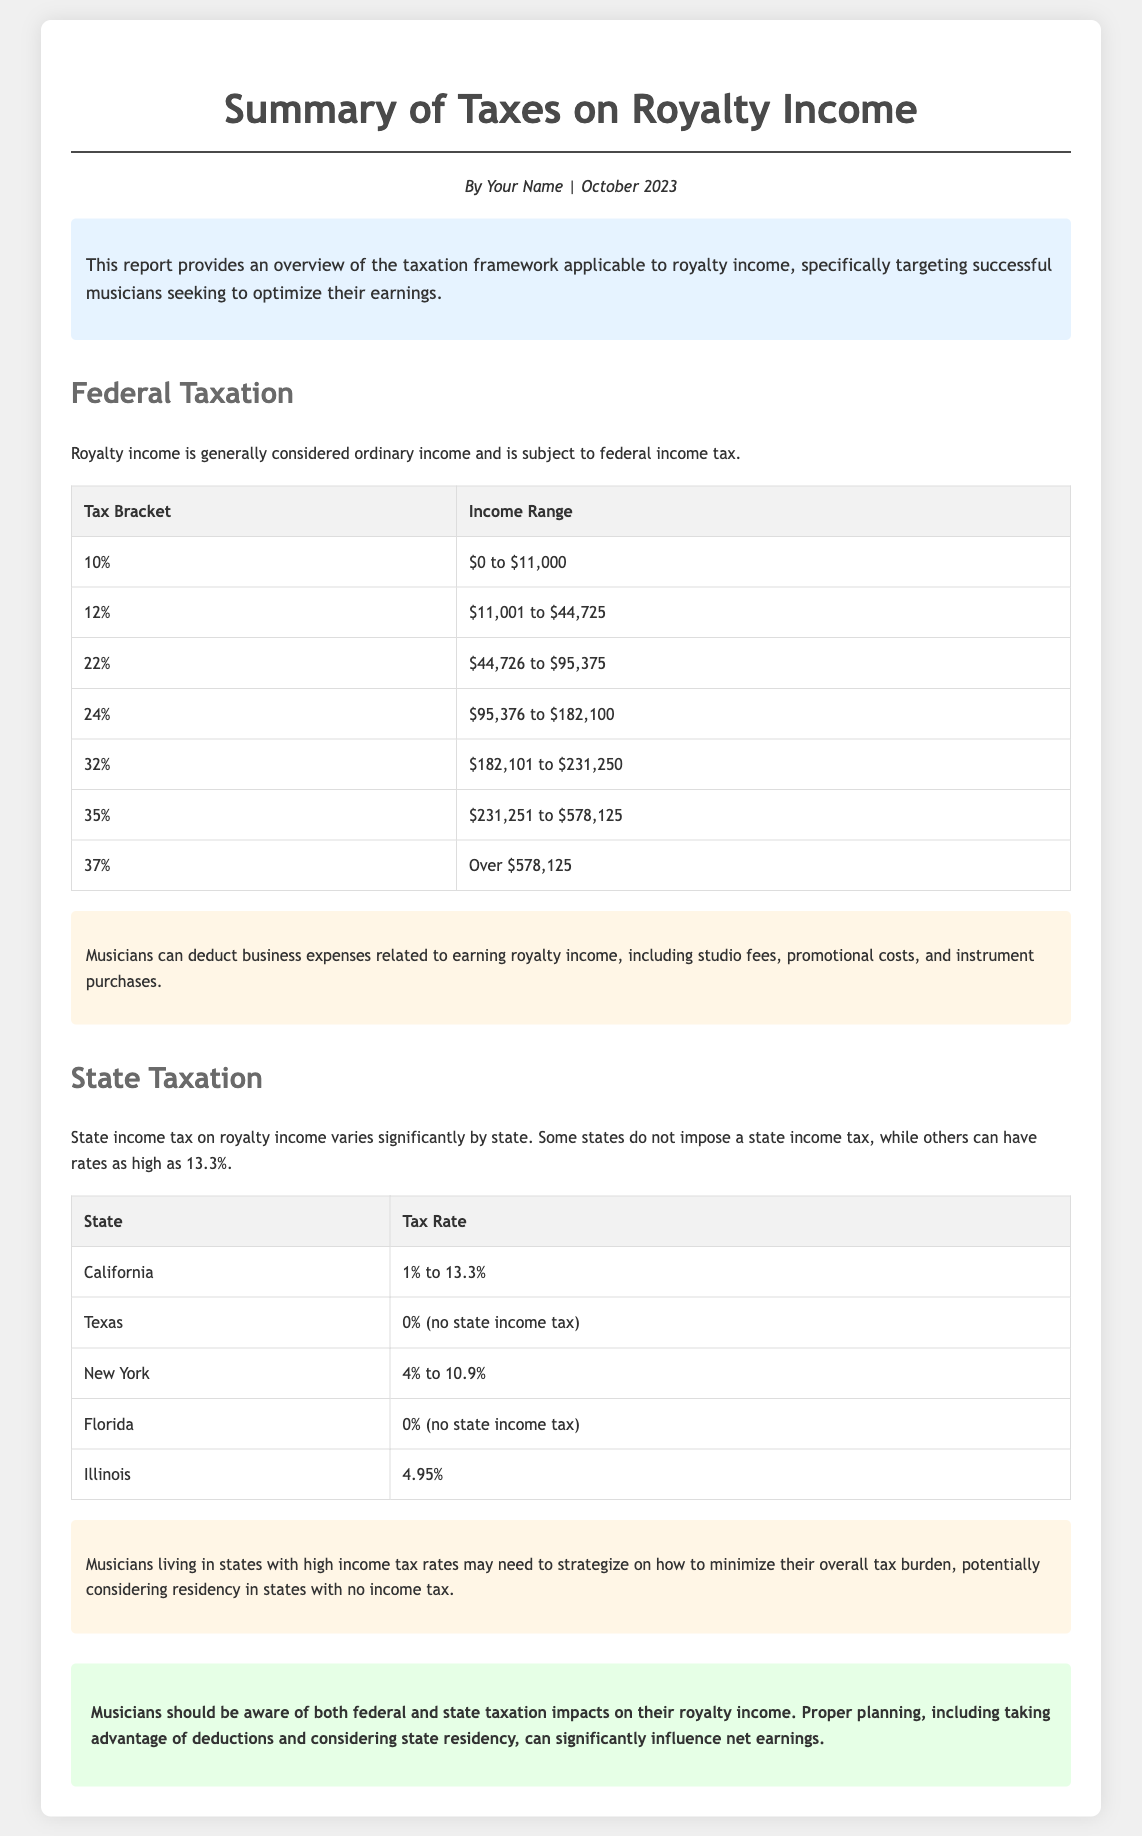What is the federal tax rate for income up to $11,000? The document lists the tax bracket of 10% for income ranging from $0 to $11,000.
Answer: 10% What is the maximum federal tax bracket mentioned in the document? The document indicates the highest tax bracket of 37% for income over $578,125.
Answer: 37% In which month and year is this report published? The author-date section states that the report is dated October 2023.
Answer: October 2023 Which state has the highest possible income tax rate on royalty income? The document specifies California with a tax rate as high as 13.3%.
Answer: California What expenses can musicians deduct from their royalty income? The document mentions studio fees, promotional costs, and instrument purchases as deductible business expenses.
Answer: Studio fees, promotional costs, instrument purchases What is the state tax rate for Texas? The report describes Texas as having no state income tax.
Answer: 0% (no state income tax) How do high-income state taxes affect musicians? The document suggests that musicians might need to strategize to minimize their tax burden.
Answer: Strategize to minimize tax burden What is emphasized for musicians regarding taxation in the summary? The summary highlights the importance of being aware of the impact of both federal and state taxes on royalty income.
Answer: Impact of both federal and state taxes How are royalties classified for federal taxation? The report indicates that royalty income is generally considered ordinary income for federal tax purposes.
Answer: Ordinary income 